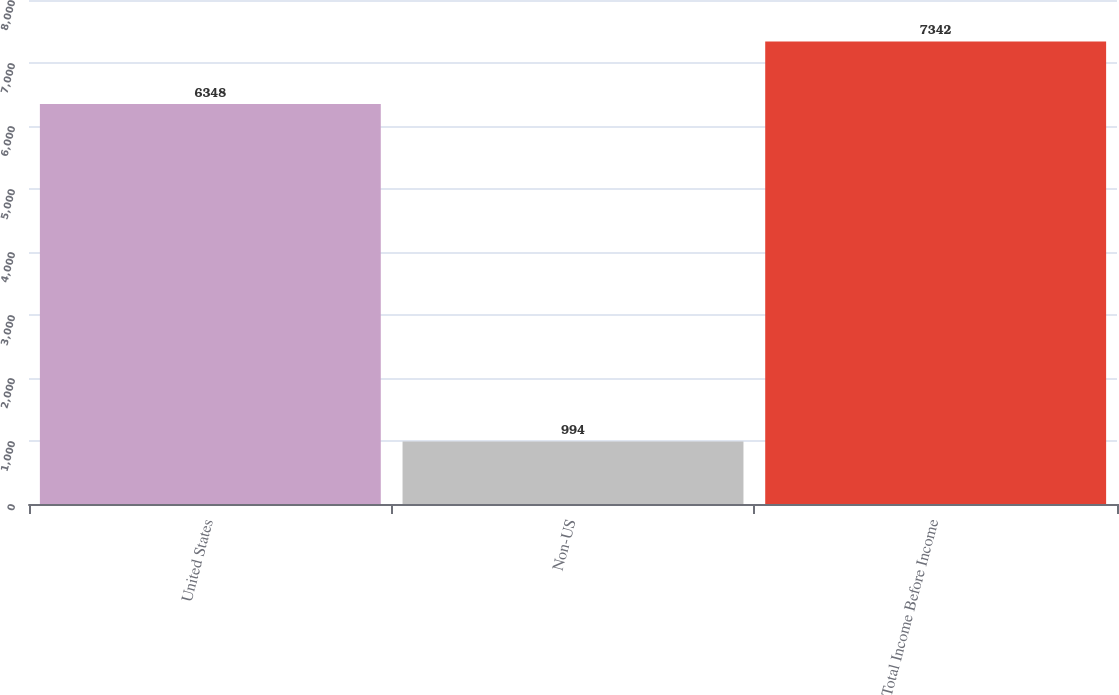Convert chart. <chart><loc_0><loc_0><loc_500><loc_500><bar_chart><fcel>United States<fcel>Non-US<fcel>Total Income Before Income<nl><fcel>6348<fcel>994<fcel>7342<nl></chart> 